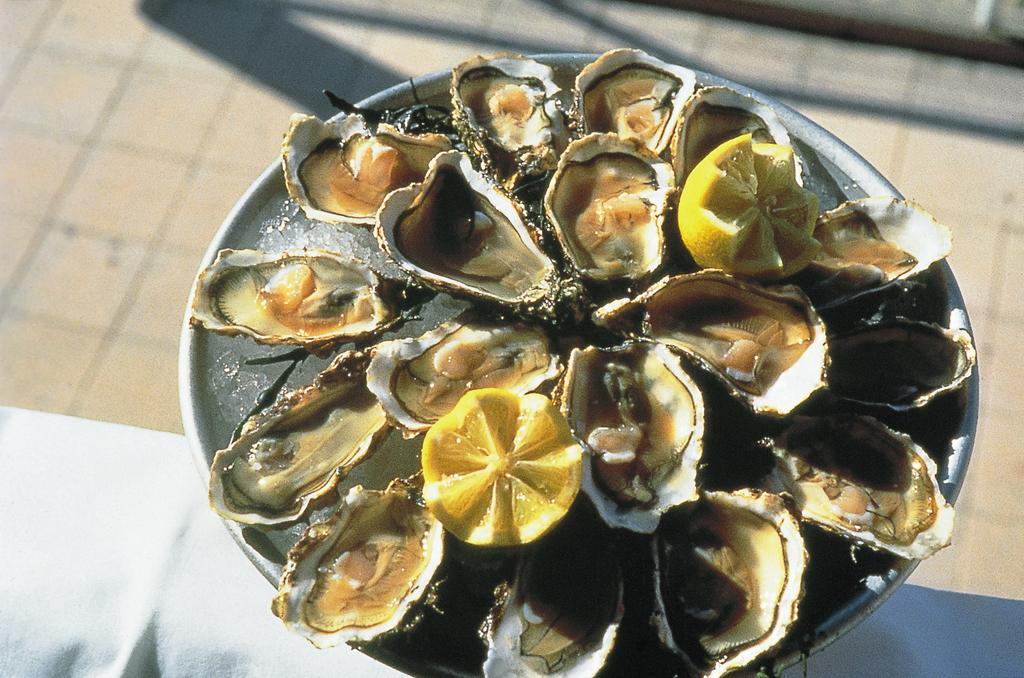What is on the plate that is visible in the image? There is a plate in the image, and it contains ice. What is inside the ice on the plate? There are shell fishes and two lemon pieces in the ice. What type of honey is drizzled over the jeans in the image? There is no honey or jeans present in the image. 